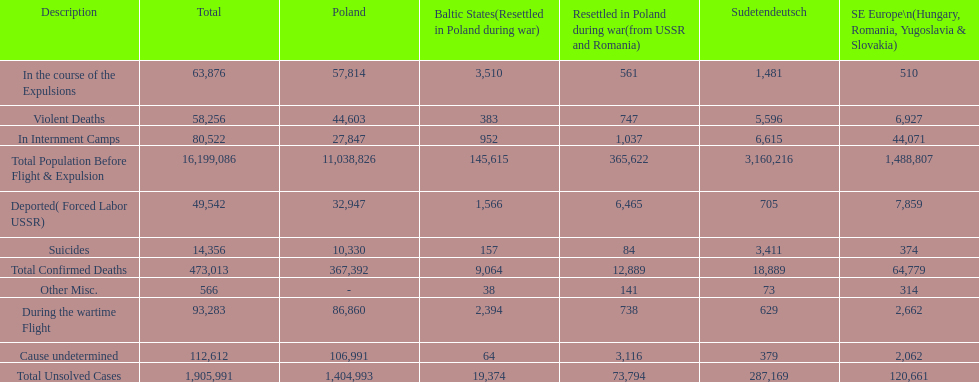How many causes were responsible for more than 50,000 confirmed deaths? 5. 